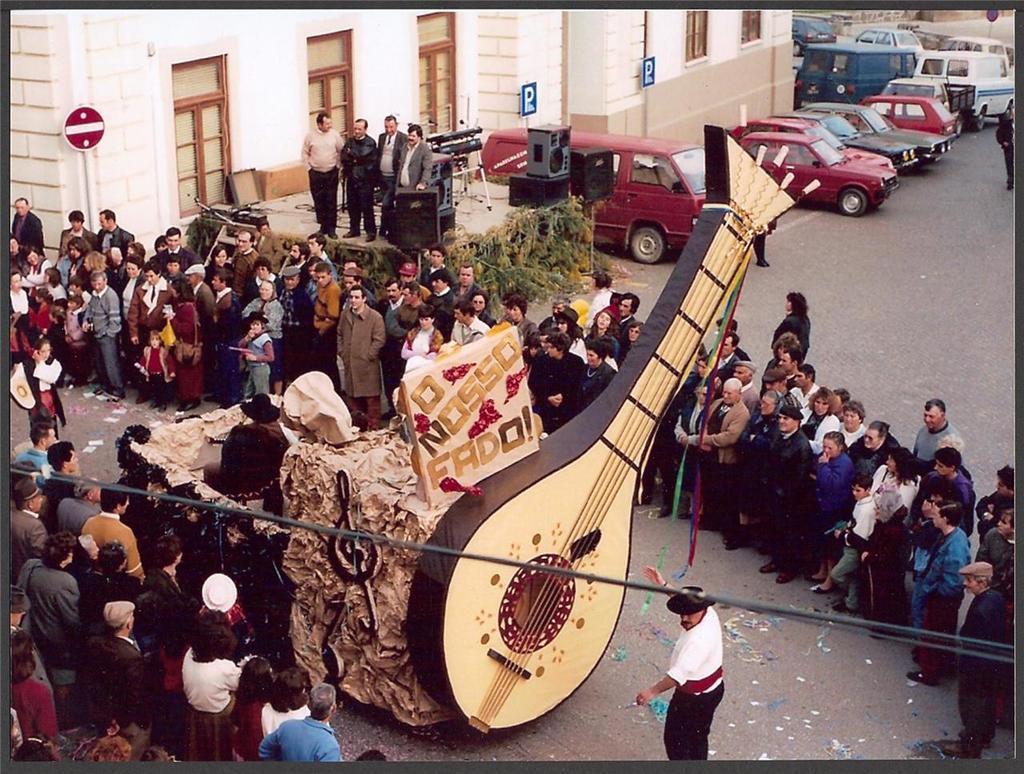Can you describe this image briefly? In this picture we can see a group of people standing on the road, vehicles, speakers, stand, plants, signboards, windows, violin and some objects and in the background we can see the wall. 